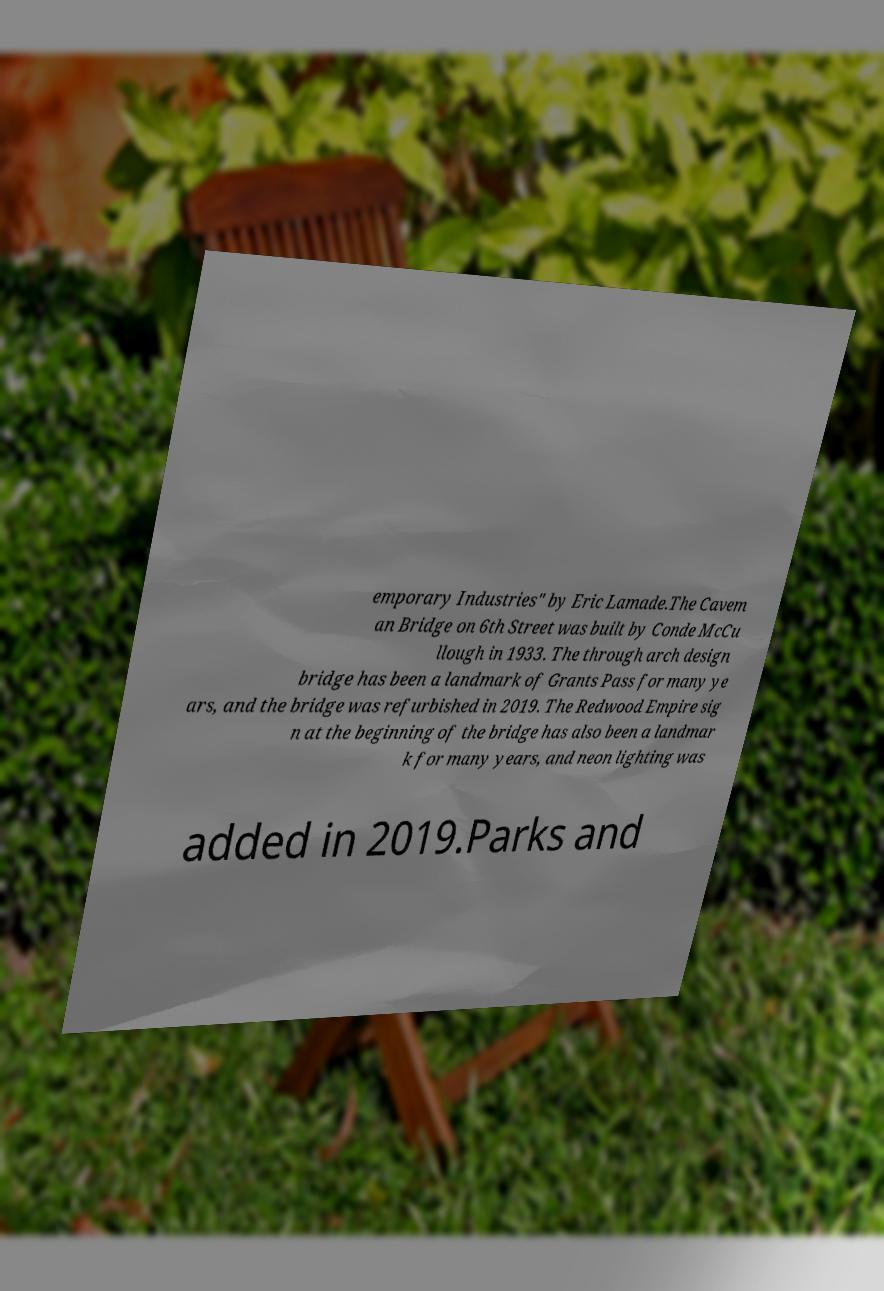Could you assist in decoding the text presented in this image and type it out clearly? emporary Industries" by Eric Lamade.The Cavem an Bridge on 6th Street was built by Conde McCu llough in 1933. The through arch design bridge has been a landmark of Grants Pass for many ye ars, and the bridge was refurbished in 2019. The Redwood Empire sig n at the beginning of the bridge has also been a landmar k for many years, and neon lighting was added in 2019.Parks and 